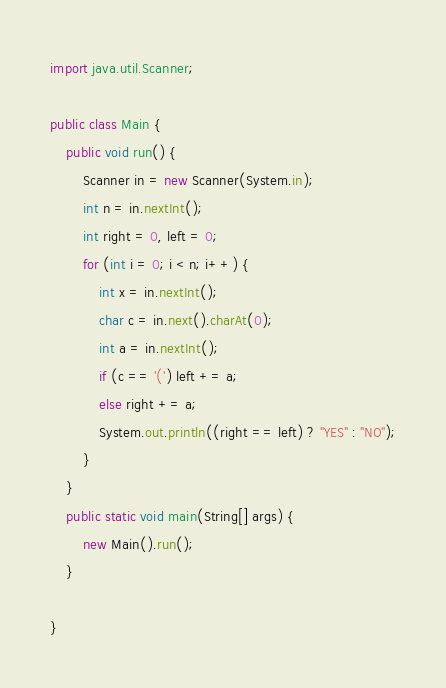<code> <loc_0><loc_0><loc_500><loc_500><_Java_>import java.util.Scanner;

public class Main {
	public void run() {
		Scanner in = new Scanner(System.in);
		int n = in.nextInt();
		int right = 0, left = 0;
		for (int i = 0; i < n; i++) {
			int x = in.nextInt();
			char c = in.next().charAt(0);
			int a = in.nextInt();
			if (c == '(') left += a;
			else right += a;
			System.out.println((right == left) ? "YES" : "NO");
		}
	}
	public static void main(String[] args) {
		new Main().run();
	}

}</code> 